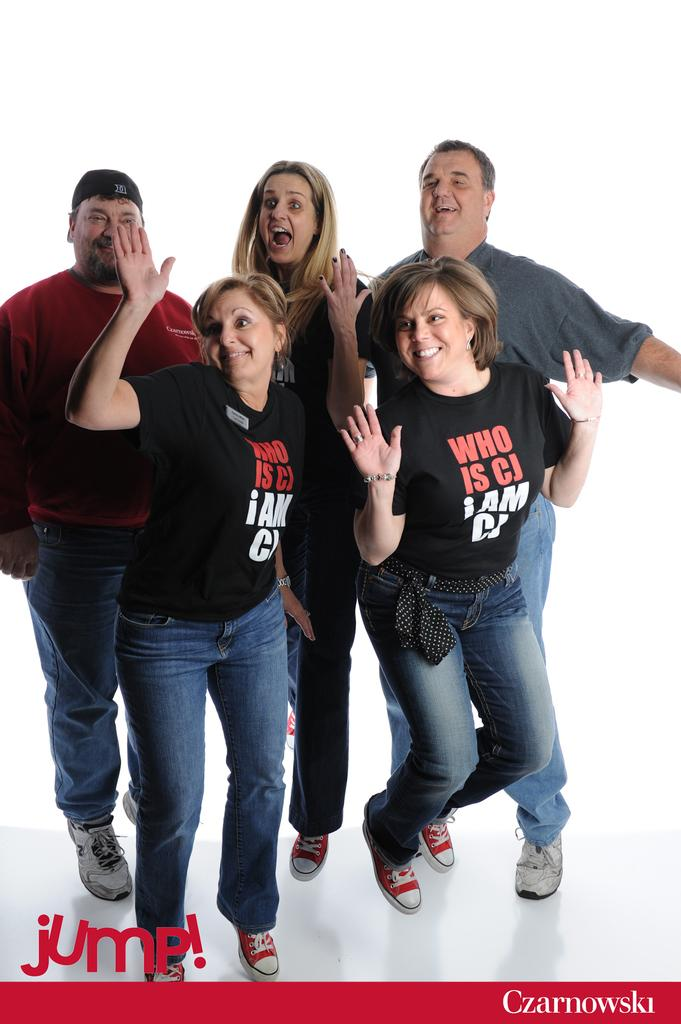Who or what is present in the image? There are people in the image. What are the people doing in the image? The people are standing in the image. How are the people feeling or expressing themselves in the image? The people are smiling in the image. What language are the people speaking in the image? There is no information about the language being spoken in the image. 